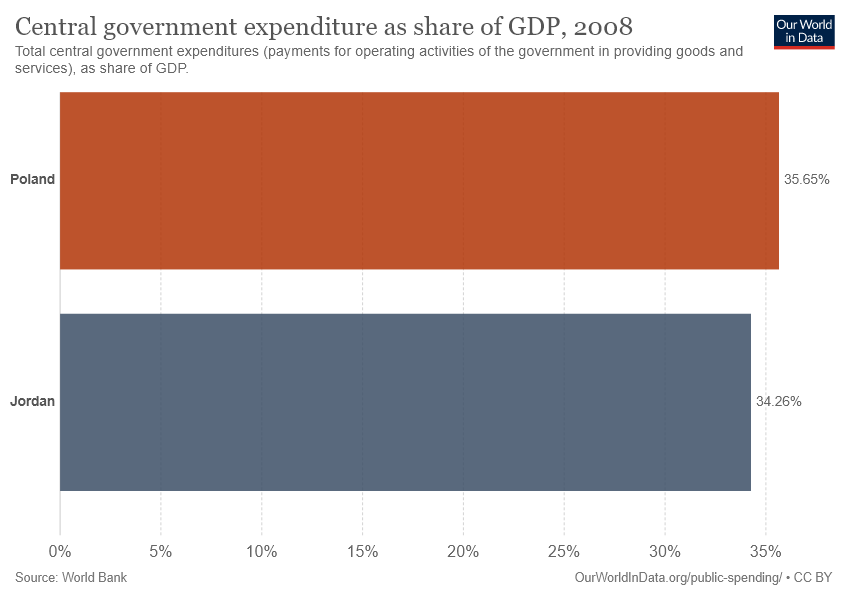How does Poland's government expenditure as a percentage of GDP compare to Jordan's in 2008? In 2008, Poland's government expenditure was slightly higher, at 35.65% of its GDP, compared to Jordan's, which was 34.26%. 